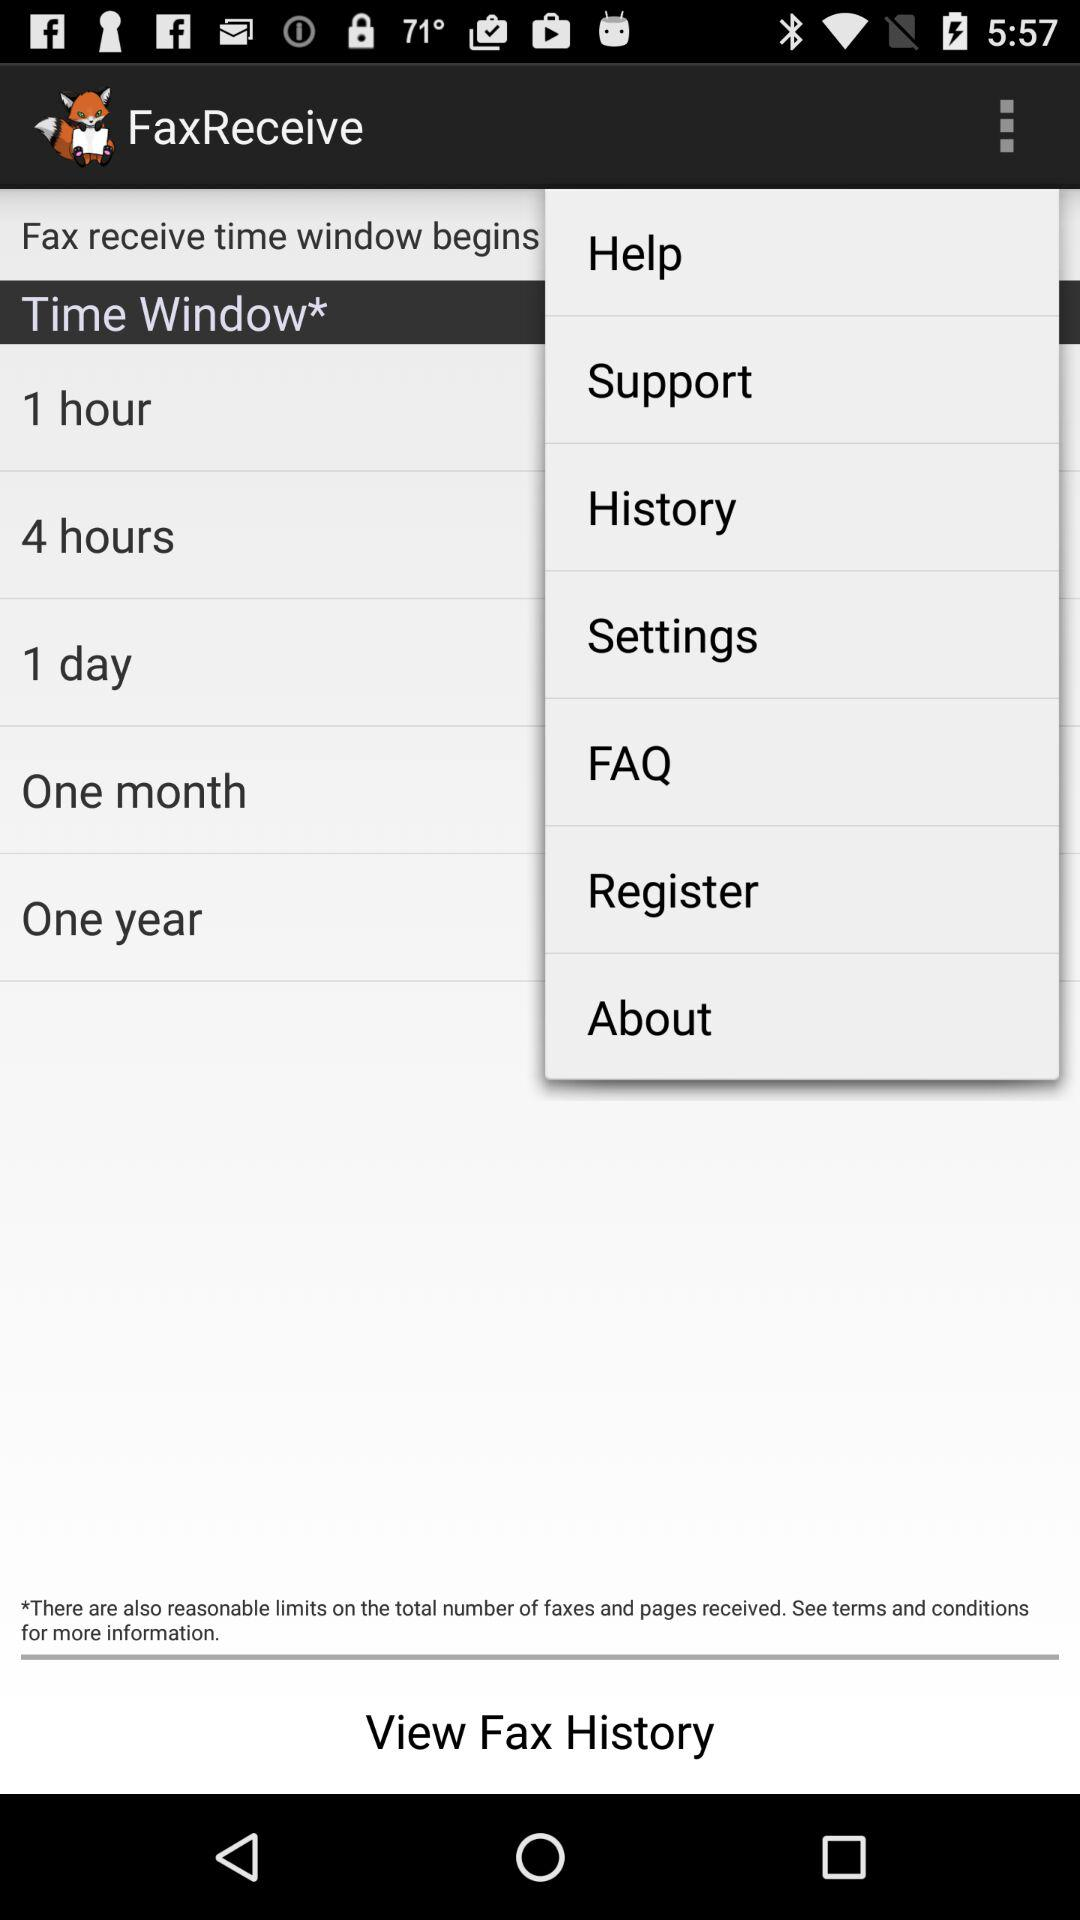How many more hours are there in the 4 hours option than in the 1 hour option?
Answer the question using a single word or phrase. 3 